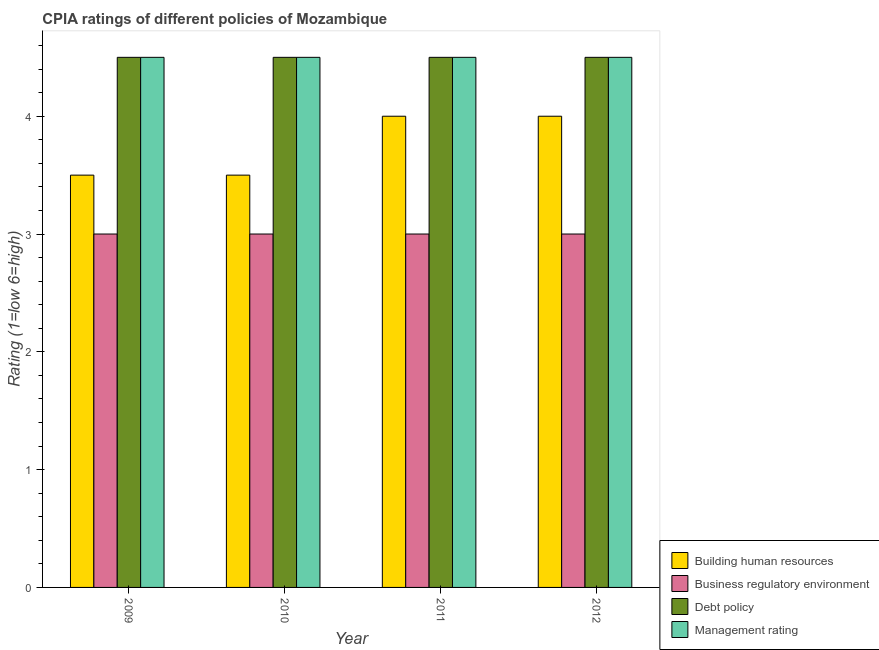Are the number of bars per tick equal to the number of legend labels?
Give a very brief answer. Yes. How many bars are there on the 4th tick from the right?
Keep it short and to the point. 4. In how many cases, is the number of bars for a given year not equal to the number of legend labels?
Make the answer very short. 0. What is the cpia rating of business regulatory environment in 2010?
Provide a short and direct response. 3. Across all years, what is the maximum cpia rating of business regulatory environment?
Offer a very short reply. 3. Across all years, what is the minimum cpia rating of building human resources?
Provide a short and direct response. 3.5. In which year was the cpia rating of business regulatory environment maximum?
Provide a short and direct response. 2009. What is the total cpia rating of building human resources in the graph?
Keep it short and to the point. 15. What is the average cpia rating of debt policy per year?
Offer a terse response. 4.5. In how many years, is the cpia rating of management greater than 3.4?
Make the answer very short. 4. What is the ratio of the cpia rating of building human resources in 2009 to that in 2010?
Make the answer very short. 1. Is the cpia rating of business regulatory environment in 2009 less than that in 2012?
Your answer should be very brief. No. What is the difference between the highest and the lowest cpia rating of management?
Give a very brief answer. 0. Is the sum of the cpia rating of building human resources in 2010 and 2011 greater than the maximum cpia rating of management across all years?
Provide a short and direct response. Yes. What does the 3rd bar from the left in 2011 represents?
Keep it short and to the point. Debt policy. What does the 2nd bar from the right in 2011 represents?
Give a very brief answer. Debt policy. Is it the case that in every year, the sum of the cpia rating of building human resources and cpia rating of business regulatory environment is greater than the cpia rating of debt policy?
Provide a succinct answer. Yes. Are all the bars in the graph horizontal?
Your answer should be very brief. No. Does the graph contain any zero values?
Provide a short and direct response. No. Does the graph contain grids?
Your answer should be very brief. No. Where does the legend appear in the graph?
Offer a very short reply. Bottom right. How many legend labels are there?
Provide a succinct answer. 4. How are the legend labels stacked?
Offer a very short reply. Vertical. What is the title of the graph?
Your answer should be very brief. CPIA ratings of different policies of Mozambique. Does "Other Minerals" appear as one of the legend labels in the graph?
Ensure brevity in your answer.  No. What is the label or title of the X-axis?
Your answer should be compact. Year. What is the Rating (1=low 6=high) in Building human resources in 2009?
Provide a succinct answer. 3.5. What is the Rating (1=low 6=high) in Business regulatory environment in 2009?
Provide a succinct answer. 3. What is the Rating (1=low 6=high) of Management rating in 2009?
Make the answer very short. 4.5. What is the Rating (1=low 6=high) in Building human resources in 2010?
Provide a succinct answer. 3.5. What is the Rating (1=low 6=high) of Debt policy in 2010?
Your answer should be compact. 4.5. What is the Rating (1=low 6=high) in Business regulatory environment in 2011?
Provide a short and direct response. 3. What is the Rating (1=low 6=high) in Business regulatory environment in 2012?
Your response must be concise. 3. What is the Rating (1=low 6=high) in Debt policy in 2012?
Make the answer very short. 4.5. What is the Rating (1=low 6=high) in Management rating in 2012?
Provide a succinct answer. 4.5. Across all years, what is the maximum Rating (1=low 6=high) in Building human resources?
Make the answer very short. 4. Across all years, what is the minimum Rating (1=low 6=high) in Debt policy?
Your response must be concise. 4.5. Across all years, what is the minimum Rating (1=low 6=high) in Management rating?
Your answer should be very brief. 4.5. What is the total Rating (1=low 6=high) in Building human resources in the graph?
Your response must be concise. 15. What is the total Rating (1=low 6=high) in Business regulatory environment in the graph?
Provide a succinct answer. 12. What is the total Rating (1=low 6=high) in Debt policy in the graph?
Provide a short and direct response. 18. What is the difference between the Rating (1=low 6=high) of Management rating in 2009 and that in 2010?
Your answer should be very brief. 0. What is the difference between the Rating (1=low 6=high) of Building human resources in 2009 and that in 2011?
Ensure brevity in your answer.  -0.5. What is the difference between the Rating (1=low 6=high) in Business regulatory environment in 2009 and that in 2011?
Your answer should be compact. 0. What is the difference between the Rating (1=low 6=high) in Debt policy in 2009 and that in 2011?
Keep it short and to the point. 0. What is the difference between the Rating (1=low 6=high) in Building human resources in 2009 and that in 2012?
Your response must be concise. -0.5. What is the difference between the Rating (1=low 6=high) of Management rating in 2009 and that in 2012?
Offer a terse response. 0. What is the difference between the Rating (1=low 6=high) of Building human resources in 2010 and that in 2011?
Keep it short and to the point. -0.5. What is the difference between the Rating (1=low 6=high) in Building human resources in 2010 and that in 2012?
Give a very brief answer. -0.5. What is the difference between the Rating (1=low 6=high) in Management rating in 2011 and that in 2012?
Ensure brevity in your answer.  0. What is the difference between the Rating (1=low 6=high) of Building human resources in 2009 and the Rating (1=low 6=high) of Business regulatory environment in 2010?
Your response must be concise. 0.5. What is the difference between the Rating (1=low 6=high) in Building human resources in 2009 and the Rating (1=low 6=high) in Business regulatory environment in 2011?
Make the answer very short. 0.5. What is the difference between the Rating (1=low 6=high) in Building human resources in 2009 and the Rating (1=low 6=high) in Debt policy in 2011?
Offer a terse response. -1. What is the difference between the Rating (1=low 6=high) in Business regulatory environment in 2009 and the Rating (1=low 6=high) in Management rating in 2011?
Your answer should be compact. -1.5. What is the difference between the Rating (1=low 6=high) in Building human resources in 2009 and the Rating (1=low 6=high) in Business regulatory environment in 2012?
Ensure brevity in your answer.  0.5. What is the difference between the Rating (1=low 6=high) of Building human resources in 2009 and the Rating (1=low 6=high) of Debt policy in 2012?
Offer a very short reply. -1. What is the difference between the Rating (1=low 6=high) of Building human resources in 2009 and the Rating (1=low 6=high) of Management rating in 2012?
Provide a short and direct response. -1. What is the difference between the Rating (1=low 6=high) in Business regulatory environment in 2009 and the Rating (1=low 6=high) in Management rating in 2012?
Offer a terse response. -1.5. What is the difference between the Rating (1=low 6=high) of Debt policy in 2009 and the Rating (1=low 6=high) of Management rating in 2012?
Give a very brief answer. 0. What is the difference between the Rating (1=low 6=high) of Business regulatory environment in 2010 and the Rating (1=low 6=high) of Management rating in 2011?
Your answer should be compact. -1.5. What is the difference between the Rating (1=low 6=high) of Building human resources in 2010 and the Rating (1=low 6=high) of Debt policy in 2012?
Provide a short and direct response. -1. What is the difference between the Rating (1=low 6=high) in Business regulatory environment in 2010 and the Rating (1=low 6=high) in Management rating in 2012?
Keep it short and to the point. -1.5. What is the difference between the Rating (1=low 6=high) of Debt policy in 2010 and the Rating (1=low 6=high) of Management rating in 2012?
Your answer should be compact. 0. What is the difference between the Rating (1=low 6=high) in Building human resources in 2011 and the Rating (1=low 6=high) in Business regulatory environment in 2012?
Provide a short and direct response. 1. What is the difference between the Rating (1=low 6=high) of Business regulatory environment in 2011 and the Rating (1=low 6=high) of Management rating in 2012?
Offer a terse response. -1.5. What is the average Rating (1=low 6=high) in Building human resources per year?
Give a very brief answer. 3.75. What is the average Rating (1=low 6=high) of Management rating per year?
Keep it short and to the point. 4.5. In the year 2009, what is the difference between the Rating (1=low 6=high) in Building human resources and Rating (1=low 6=high) in Business regulatory environment?
Your response must be concise. 0.5. In the year 2009, what is the difference between the Rating (1=low 6=high) in Building human resources and Rating (1=low 6=high) in Debt policy?
Provide a short and direct response. -1. In the year 2009, what is the difference between the Rating (1=low 6=high) in Building human resources and Rating (1=low 6=high) in Management rating?
Ensure brevity in your answer.  -1. In the year 2009, what is the difference between the Rating (1=low 6=high) in Business regulatory environment and Rating (1=low 6=high) in Debt policy?
Your answer should be compact. -1.5. In the year 2010, what is the difference between the Rating (1=low 6=high) in Building human resources and Rating (1=low 6=high) in Business regulatory environment?
Offer a very short reply. 0.5. In the year 2010, what is the difference between the Rating (1=low 6=high) of Building human resources and Rating (1=low 6=high) of Debt policy?
Provide a short and direct response. -1. In the year 2010, what is the difference between the Rating (1=low 6=high) in Business regulatory environment and Rating (1=low 6=high) in Debt policy?
Keep it short and to the point. -1.5. In the year 2011, what is the difference between the Rating (1=low 6=high) of Building human resources and Rating (1=low 6=high) of Business regulatory environment?
Your answer should be very brief. 1. In the year 2011, what is the difference between the Rating (1=low 6=high) in Building human resources and Rating (1=low 6=high) in Debt policy?
Keep it short and to the point. -0.5. In the year 2011, what is the difference between the Rating (1=low 6=high) of Building human resources and Rating (1=low 6=high) of Management rating?
Provide a succinct answer. -0.5. In the year 2011, what is the difference between the Rating (1=low 6=high) in Debt policy and Rating (1=low 6=high) in Management rating?
Give a very brief answer. 0. In the year 2012, what is the difference between the Rating (1=low 6=high) of Building human resources and Rating (1=low 6=high) of Business regulatory environment?
Provide a short and direct response. 1. In the year 2012, what is the difference between the Rating (1=low 6=high) of Building human resources and Rating (1=low 6=high) of Debt policy?
Give a very brief answer. -0.5. In the year 2012, what is the difference between the Rating (1=low 6=high) in Building human resources and Rating (1=low 6=high) in Management rating?
Your answer should be very brief. -0.5. In the year 2012, what is the difference between the Rating (1=low 6=high) in Business regulatory environment and Rating (1=low 6=high) in Debt policy?
Your answer should be compact. -1.5. What is the ratio of the Rating (1=low 6=high) in Building human resources in 2009 to that in 2011?
Your answer should be very brief. 0.88. What is the ratio of the Rating (1=low 6=high) in Business regulatory environment in 2009 to that in 2011?
Give a very brief answer. 1. What is the ratio of the Rating (1=low 6=high) in Business regulatory environment in 2009 to that in 2012?
Provide a short and direct response. 1. What is the ratio of the Rating (1=low 6=high) in Building human resources in 2010 to that in 2011?
Ensure brevity in your answer.  0.88. What is the ratio of the Rating (1=low 6=high) of Business regulatory environment in 2010 to that in 2011?
Offer a terse response. 1. What is the ratio of the Rating (1=low 6=high) of Building human resources in 2010 to that in 2012?
Ensure brevity in your answer.  0.88. What is the ratio of the Rating (1=low 6=high) of Business regulatory environment in 2010 to that in 2012?
Provide a succinct answer. 1. What is the difference between the highest and the second highest Rating (1=low 6=high) in Building human resources?
Keep it short and to the point. 0. What is the difference between the highest and the lowest Rating (1=low 6=high) in Debt policy?
Your answer should be compact. 0. What is the difference between the highest and the lowest Rating (1=low 6=high) in Management rating?
Ensure brevity in your answer.  0. 